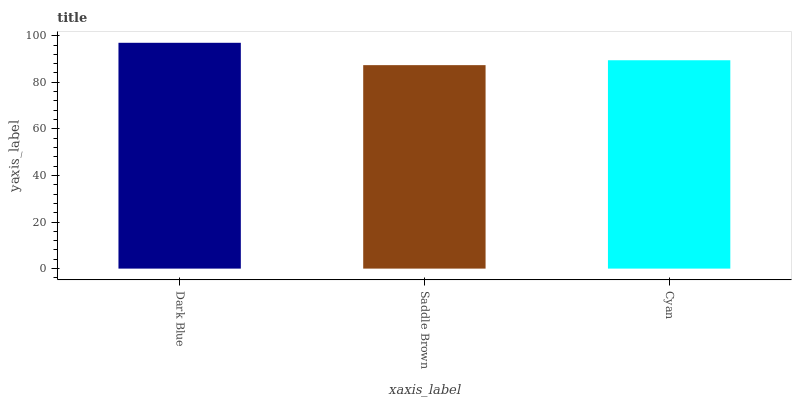Is Saddle Brown the minimum?
Answer yes or no. Yes. Is Dark Blue the maximum?
Answer yes or no. Yes. Is Cyan the minimum?
Answer yes or no. No. Is Cyan the maximum?
Answer yes or no. No. Is Cyan greater than Saddle Brown?
Answer yes or no. Yes. Is Saddle Brown less than Cyan?
Answer yes or no. Yes. Is Saddle Brown greater than Cyan?
Answer yes or no. No. Is Cyan less than Saddle Brown?
Answer yes or no. No. Is Cyan the high median?
Answer yes or no. Yes. Is Cyan the low median?
Answer yes or no. Yes. Is Saddle Brown the high median?
Answer yes or no. No. Is Saddle Brown the low median?
Answer yes or no. No. 